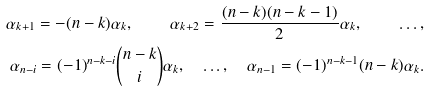<formula> <loc_0><loc_0><loc_500><loc_500>\alpha _ { k + 1 } = - ( n - k ) \alpha _ { k } , \quad \alpha _ { k + 2 } = \frac { ( n - k ) ( n - k - 1 ) } { 2 } \alpha _ { k } , \quad \dots , \\ \alpha _ { n - i } = ( - 1 ) ^ { n - k - i } \binom { n - k } { i } \alpha _ { k } , \quad \dots , \quad \alpha _ { n - 1 } = ( - 1 ) ^ { n - k - 1 } ( n - k ) \alpha _ { k } .</formula> 